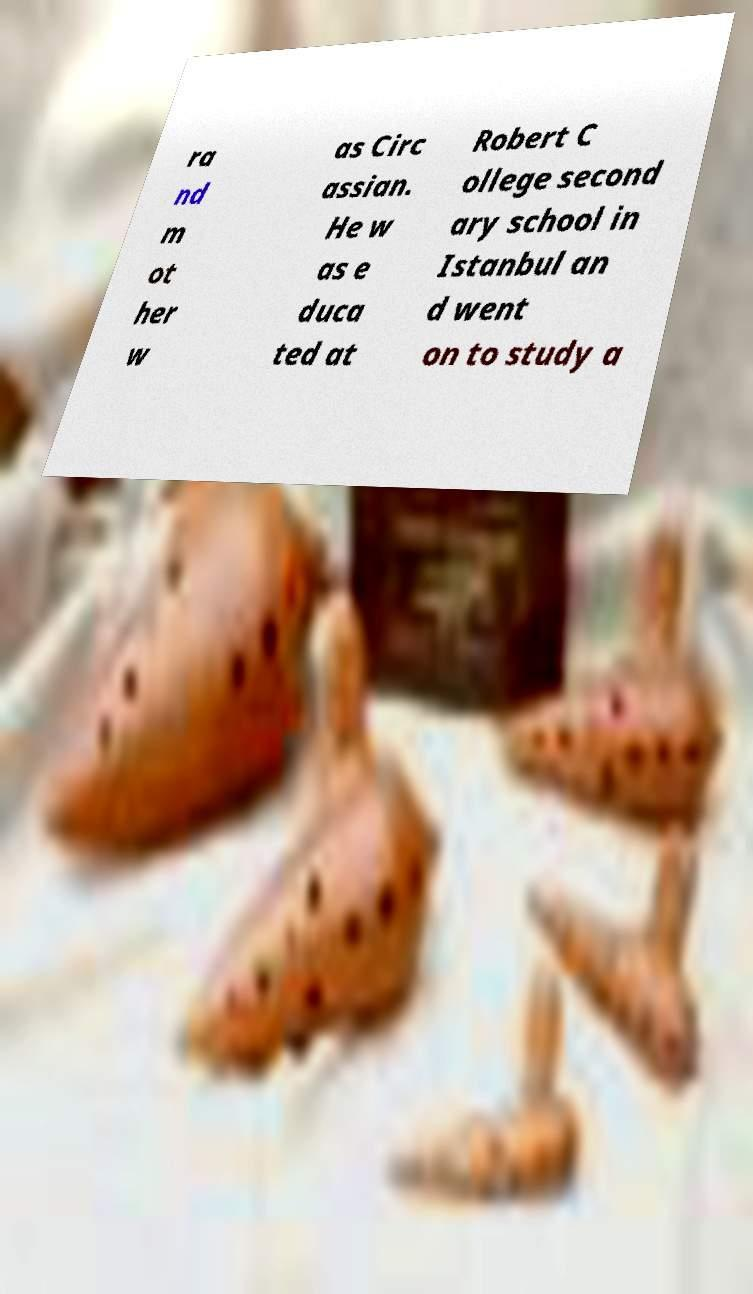There's text embedded in this image that I need extracted. Can you transcribe it verbatim? ra nd m ot her w as Circ assian. He w as e duca ted at Robert C ollege second ary school in Istanbul an d went on to study a 